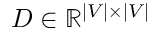<formula> <loc_0><loc_0><loc_500><loc_500>D \in \mathbb { R } ^ { | V | \times | V | }</formula> 